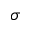Convert formula to latex. <formula><loc_0><loc_0><loc_500><loc_500>\sigma</formula> 